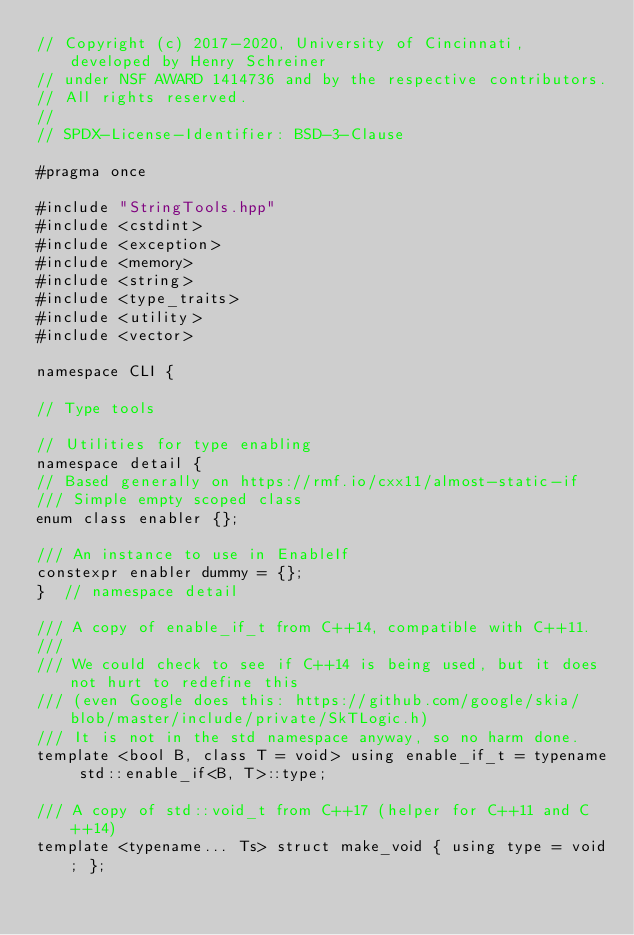<code> <loc_0><loc_0><loc_500><loc_500><_C++_>// Copyright (c) 2017-2020, University of Cincinnati, developed by Henry Schreiner
// under NSF AWARD 1414736 and by the respective contributors.
// All rights reserved.
//
// SPDX-License-Identifier: BSD-3-Clause

#pragma once

#include "StringTools.hpp"
#include <cstdint>
#include <exception>
#include <memory>
#include <string>
#include <type_traits>
#include <utility>
#include <vector>

namespace CLI {

// Type tools

// Utilities for type enabling
namespace detail {
// Based generally on https://rmf.io/cxx11/almost-static-if
/// Simple empty scoped class
enum class enabler {};

/// An instance to use in EnableIf
constexpr enabler dummy = {};
}  // namespace detail

/// A copy of enable_if_t from C++14, compatible with C++11.
///
/// We could check to see if C++14 is being used, but it does not hurt to redefine this
/// (even Google does this: https://github.com/google/skia/blob/master/include/private/SkTLogic.h)
/// It is not in the std namespace anyway, so no harm done.
template <bool B, class T = void> using enable_if_t = typename std::enable_if<B, T>::type;

/// A copy of std::void_t from C++17 (helper for C++11 and C++14)
template <typename... Ts> struct make_void { using type = void; };
</code> 